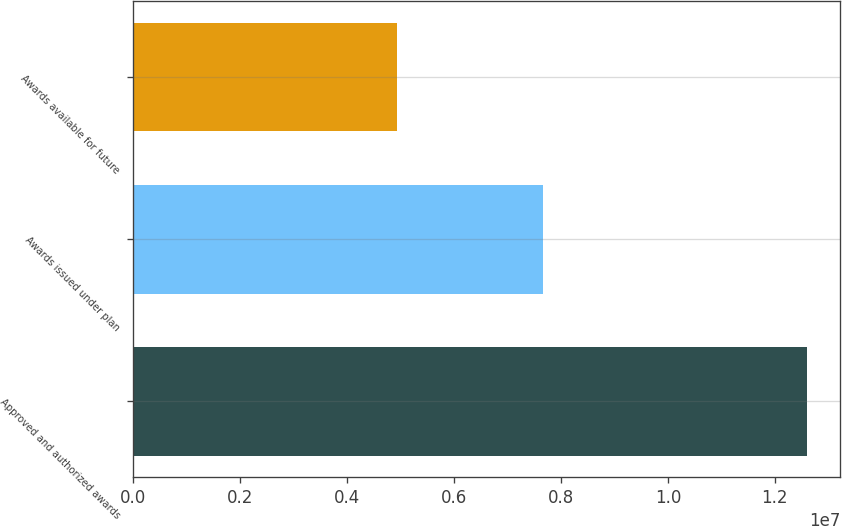Convert chart to OTSL. <chart><loc_0><loc_0><loc_500><loc_500><bar_chart><fcel>Approved and authorized awards<fcel>Awards issued under plan<fcel>Awards available for future<nl><fcel>1.26e+07<fcel>7.65776e+06<fcel>4.94224e+06<nl></chart> 